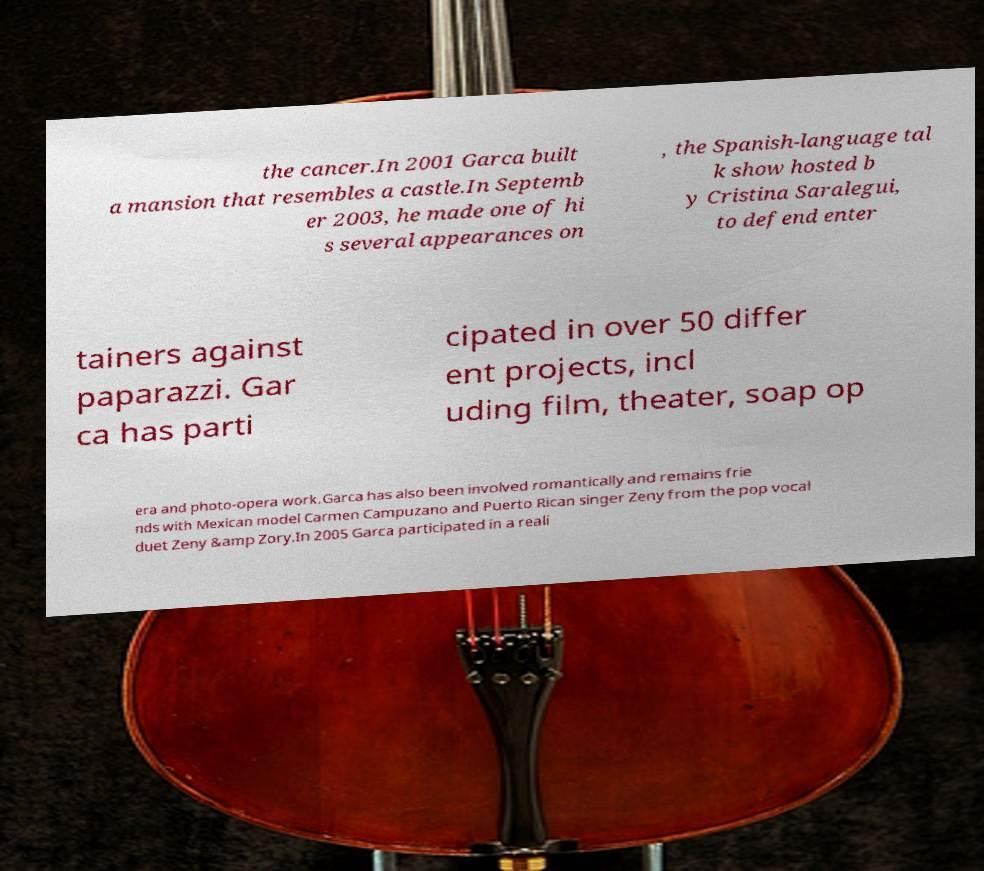Could you extract and type out the text from this image? the cancer.In 2001 Garca built a mansion that resembles a castle.In Septemb er 2003, he made one of hi s several appearances on , the Spanish-language tal k show hosted b y Cristina Saralegui, to defend enter tainers against paparazzi. Gar ca has parti cipated in over 50 differ ent projects, incl uding film, theater, soap op era and photo-opera work.Garca has also been involved romantically and remains frie nds with Mexican model Carmen Campuzano and Puerto Rican singer Zeny from the pop vocal duet Zeny &amp Zory.In 2005 Garca participated in a reali 